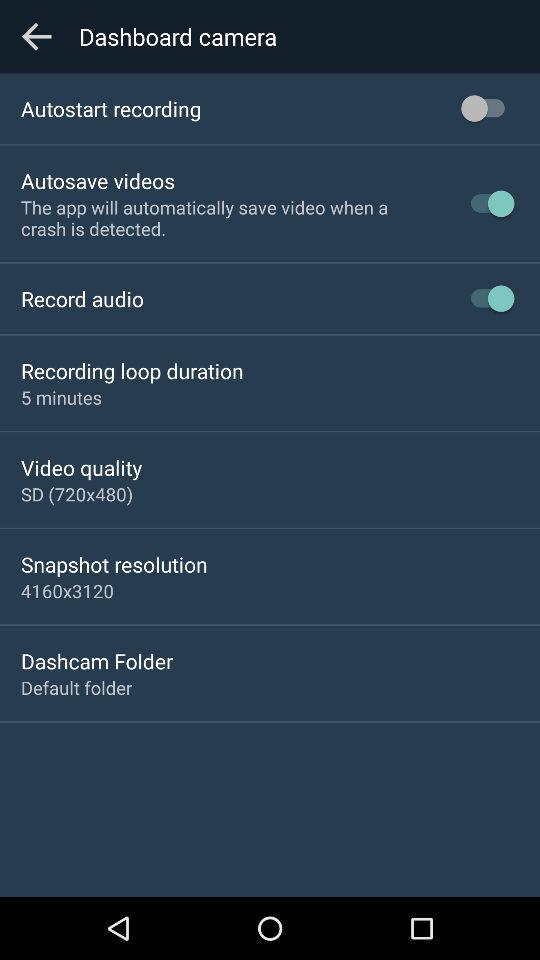What is the current status of "Autosave videos"? The current status is "on". 